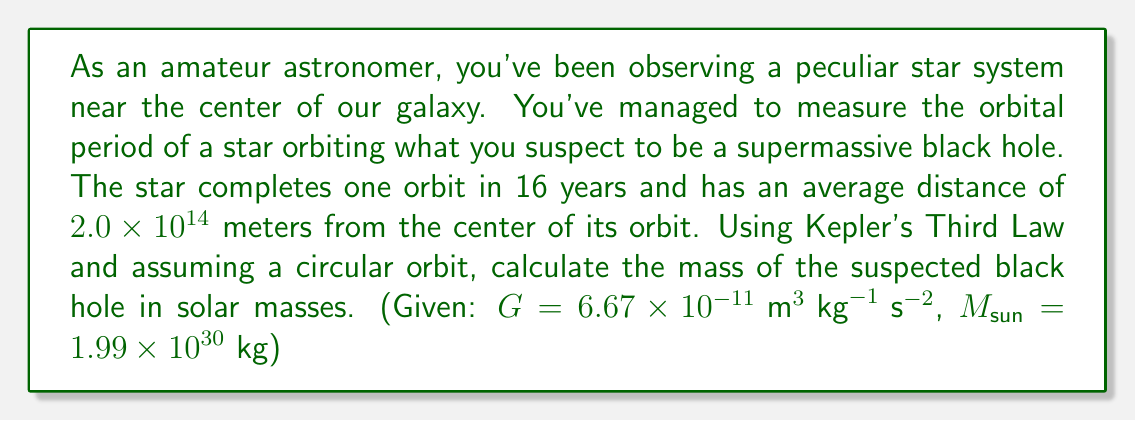What is the answer to this math problem? Let's approach this step-by-step:

1) Kepler's Third Law for circular orbits states:

   $$T^2 = \frac{4\pi^2}{GM}r^3$$

   Where $T$ is the orbital period, $G$ is the gravitational constant, $M$ is the mass of the central body (in this case, the black hole), and $r$ is the orbital radius.

2) We're given:
   $T = 16 \text{ years} = 16 \times 365.25 \times 24 \times 3600 = 5.05 \times 10^8 \text{ seconds}$
   $r = 2.0 \times 10^{14} \text{ meters}$

3) Let's rearrange Kepler's Third Law to solve for $M$:

   $$M = \frac{4\pi^2r^3}{GT^2}$$

4) Now, let's substitute our values:

   $$M = \frac{4\pi^2(2.0 \times 10^{14})^3}{(6.67 \times 10^{-11})(5.05 \times 10^8)^2}$$

5) Calculate:

   $$M = 7.96 \times 10^{36} \text{ kg}$$

6) To convert to solar masses, divide by the mass of the Sun:

   $$M_{\text{solar}} = \frac{7.96 \times 10^{36}}{1.99 \times 10^{30}} = 4.0 \times 10^6 \text{ solar masses}$$
Answer: $4.0 \times 10^6 M_{\text{sun}}$ 